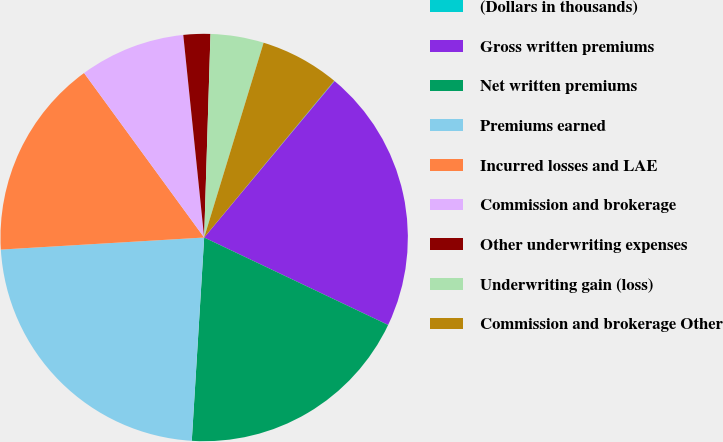<chart> <loc_0><loc_0><loc_500><loc_500><pie_chart><fcel>(Dollars in thousands)<fcel>Gross written premiums<fcel>Net written premiums<fcel>Premiums earned<fcel>Incurred losses and LAE<fcel>Commission and brokerage<fcel>Other underwriting expenses<fcel>Underwriting gain (loss)<fcel>Commission and brokerage Other<nl><fcel>0.04%<fcel>21.0%<fcel>18.91%<fcel>23.09%<fcel>15.91%<fcel>8.4%<fcel>2.13%<fcel>4.22%<fcel>6.31%<nl></chart> 